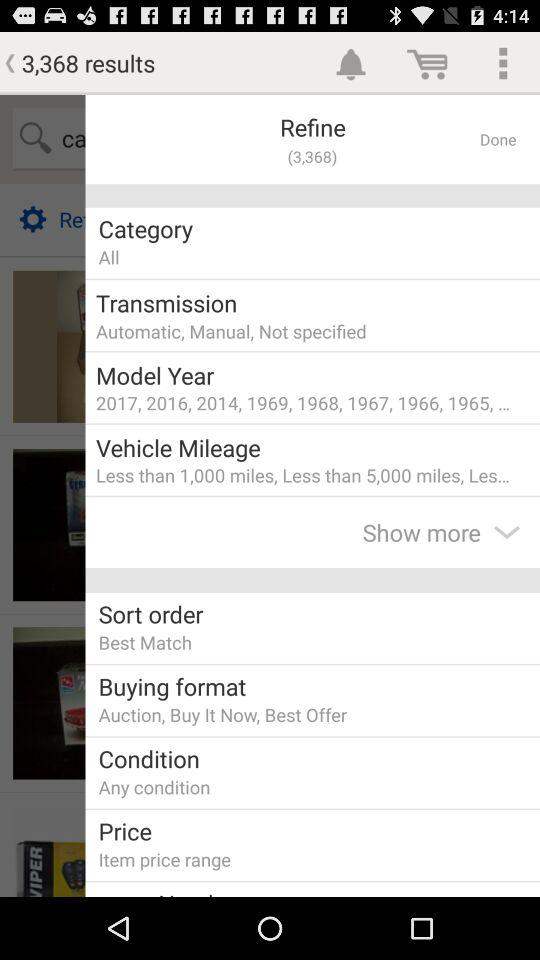What is the count of results? The count of results is 3,368. 